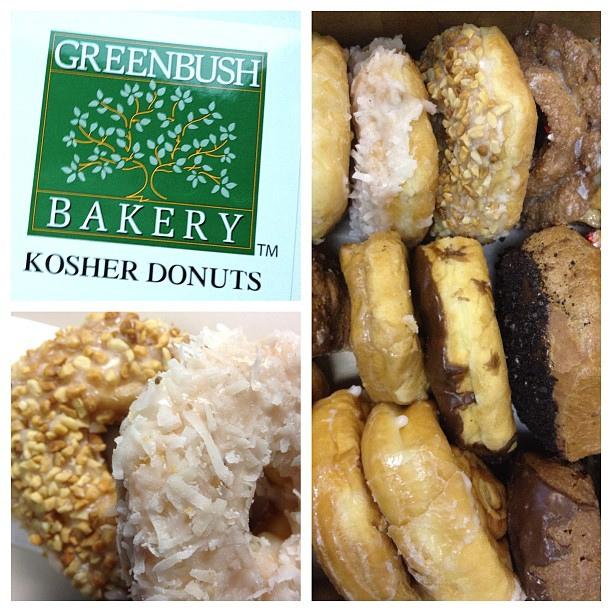How many doughnuts can be seen?
Short answer required. 13. What is in the box?
Be succinct. Donuts. What does the menu say?
Keep it brief. Kosher donuts. What is the name of the bakery?
Give a very brief answer. Greenbush bakery. 